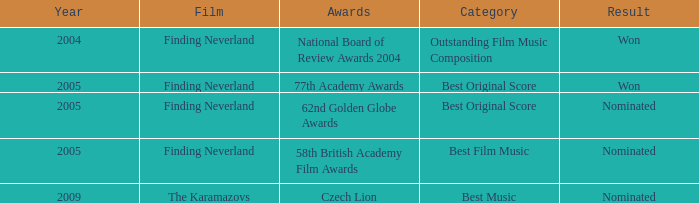What was the result for years prior to 2005? Won. 